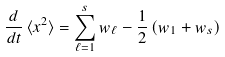Convert formula to latex. <formula><loc_0><loc_0><loc_500><loc_500>\frac { d } { d t } \, \langle x ^ { 2 } \rangle = \sum _ { \ell = 1 } ^ { s } w _ { \ell } - \frac { 1 } { 2 } \left ( w _ { 1 } + w _ { s } \right )</formula> 